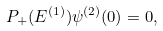<formula> <loc_0><loc_0><loc_500><loc_500>P _ { + } ( E ^ { ( 1 ) } ) \psi ^ { ( 2 ) } ( 0 ) = 0 ,</formula> 